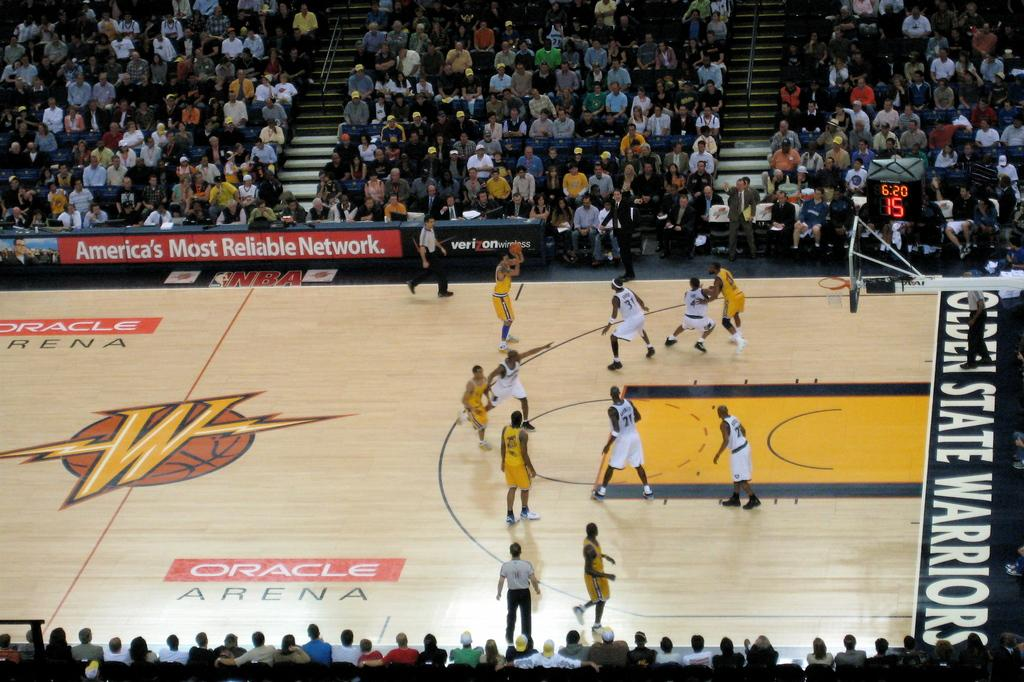<image>
Write a terse but informative summary of the picture. The basket ball court has the words "oracle arena" on it. 